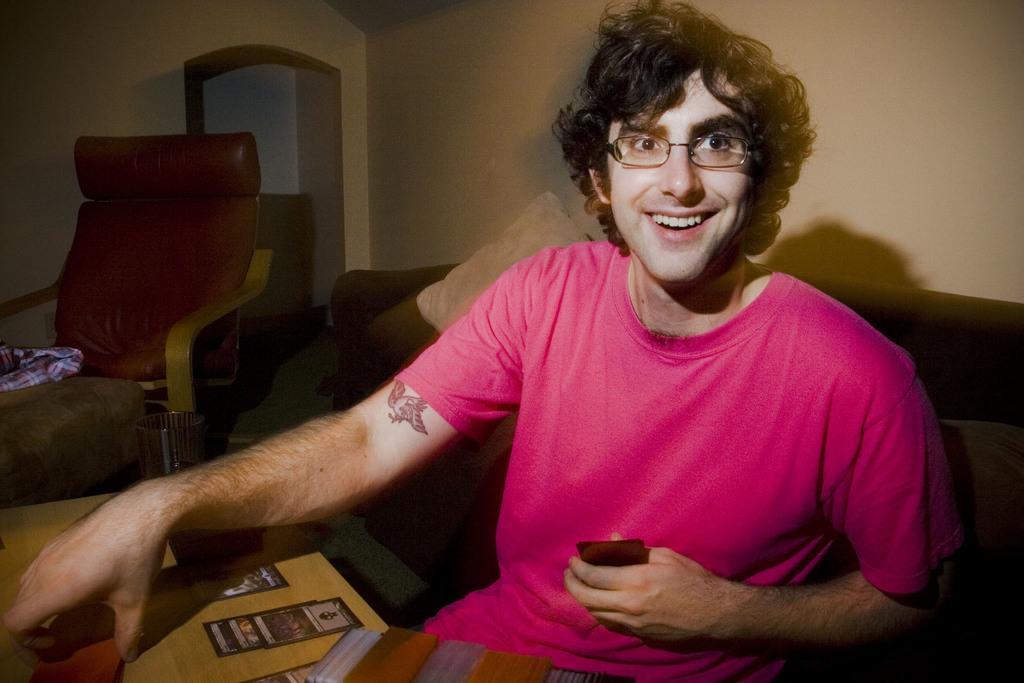Can you describe this image briefly? In the given image we can see a person sitting on a chair. This is a sofa chair and he is holding an object in his hand. 